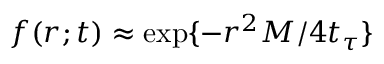<formula> <loc_0><loc_0><loc_500><loc_500>f ( r ; t ) \approx \exp \{ - r ^ { 2 } M / 4 t _ { \tau } \}</formula> 